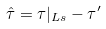<formula> <loc_0><loc_0><loc_500><loc_500>\hat { \tau } = \tau | _ { L s } - \tau ^ { \prime }</formula> 